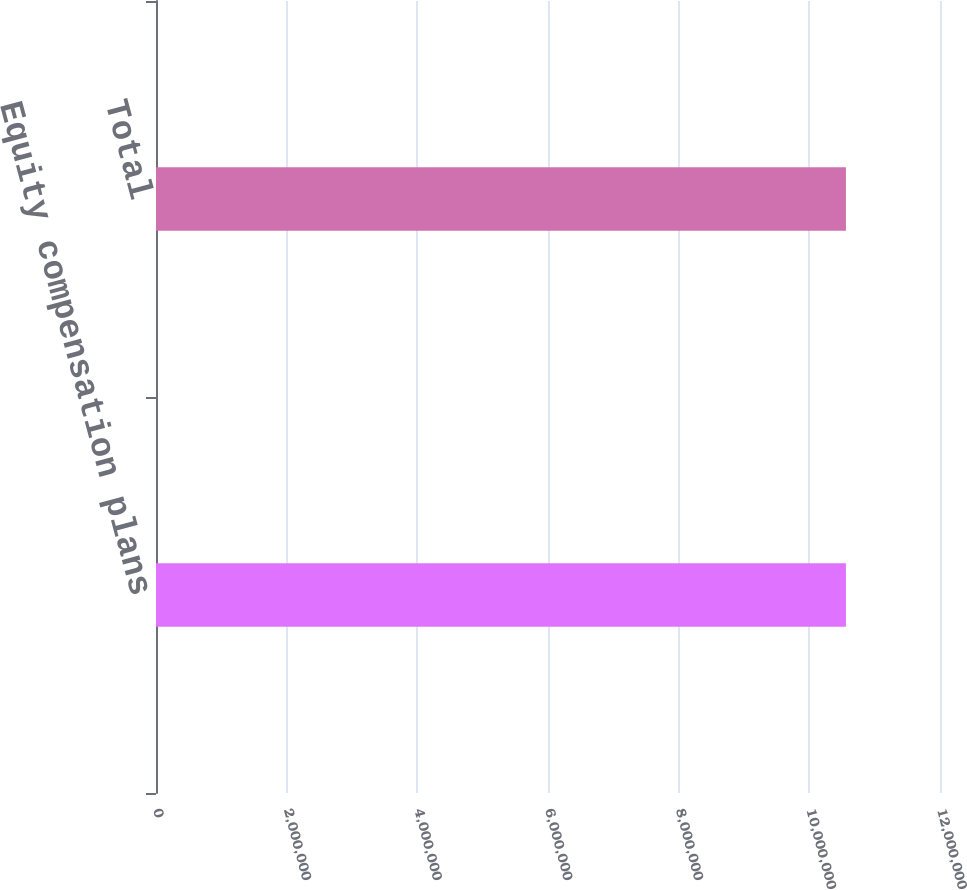Convert chart. <chart><loc_0><loc_0><loc_500><loc_500><bar_chart><fcel>Equity compensation plans<fcel>Total<nl><fcel>1.05603e+07<fcel>1.05603e+07<nl></chart> 